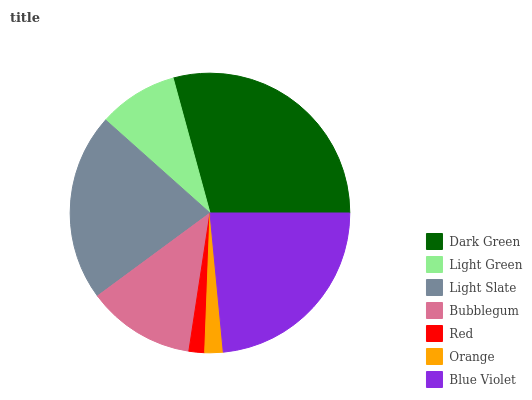Is Red the minimum?
Answer yes or no. Yes. Is Dark Green the maximum?
Answer yes or no. Yes. Is Light Green the minimum?
Answer yes or no. No. Is Light Green the maximum?
Answer yes or no. No. Is Dark Green greater than Light Green?
Answer yes or no. Yes. Is Light Green less than Dark Green?
Answer yes or no. Yes. Is Light Green greater than Dark Green?
Answer yes or no. No. Is Dark Green less than Light Green?
Answer yes or no. No. Is Bubblegum the high median?
Answer yes or no. Yes. Is Bubblegum the low median?
Answer yes or no. Yes. Is Dark Green the high median?
Answer yes or no. No. Is Red the low median?
Answer yes or no. No. 